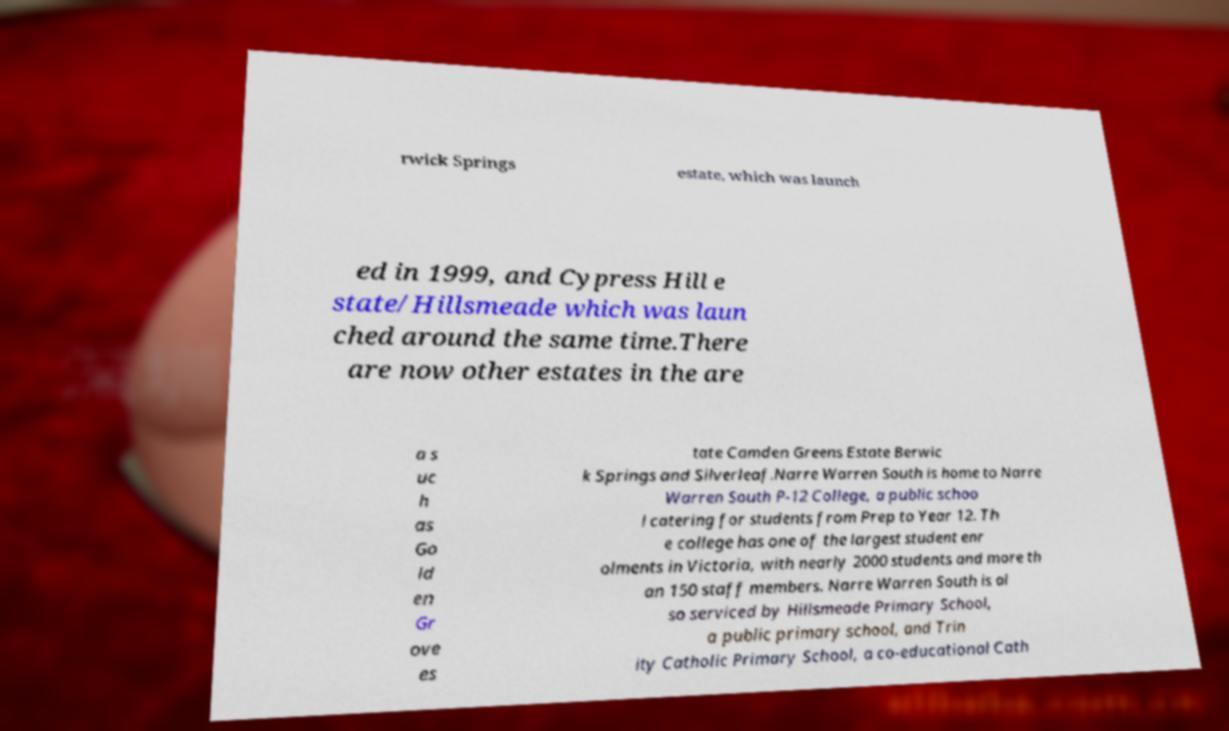Could you assist in decoding the text presented in this image and type it out clearly? rwick Springs estate, which was launch ed in 1999, and Cypress Hill e state/Hillsmeade which was laun ched around the same time.There are now other estates in the are a s uc h as Go ld en Gr ove es tate Camden Greens Estate Berwic k Springs and Silverleaf.Narre Warren South is home to Narre Warren South P-12 College, a public schoo l catering for students from Prep to Year 12. Th e college has one of the largest student enr olments in Victoria, with nearly 2000 students and more th an 150 staff members. Narre Warren South is al so serviced by Hillsmeade Primary School, a public primary school, and Trin ity Catholic Primary School, a co-educational Cath 